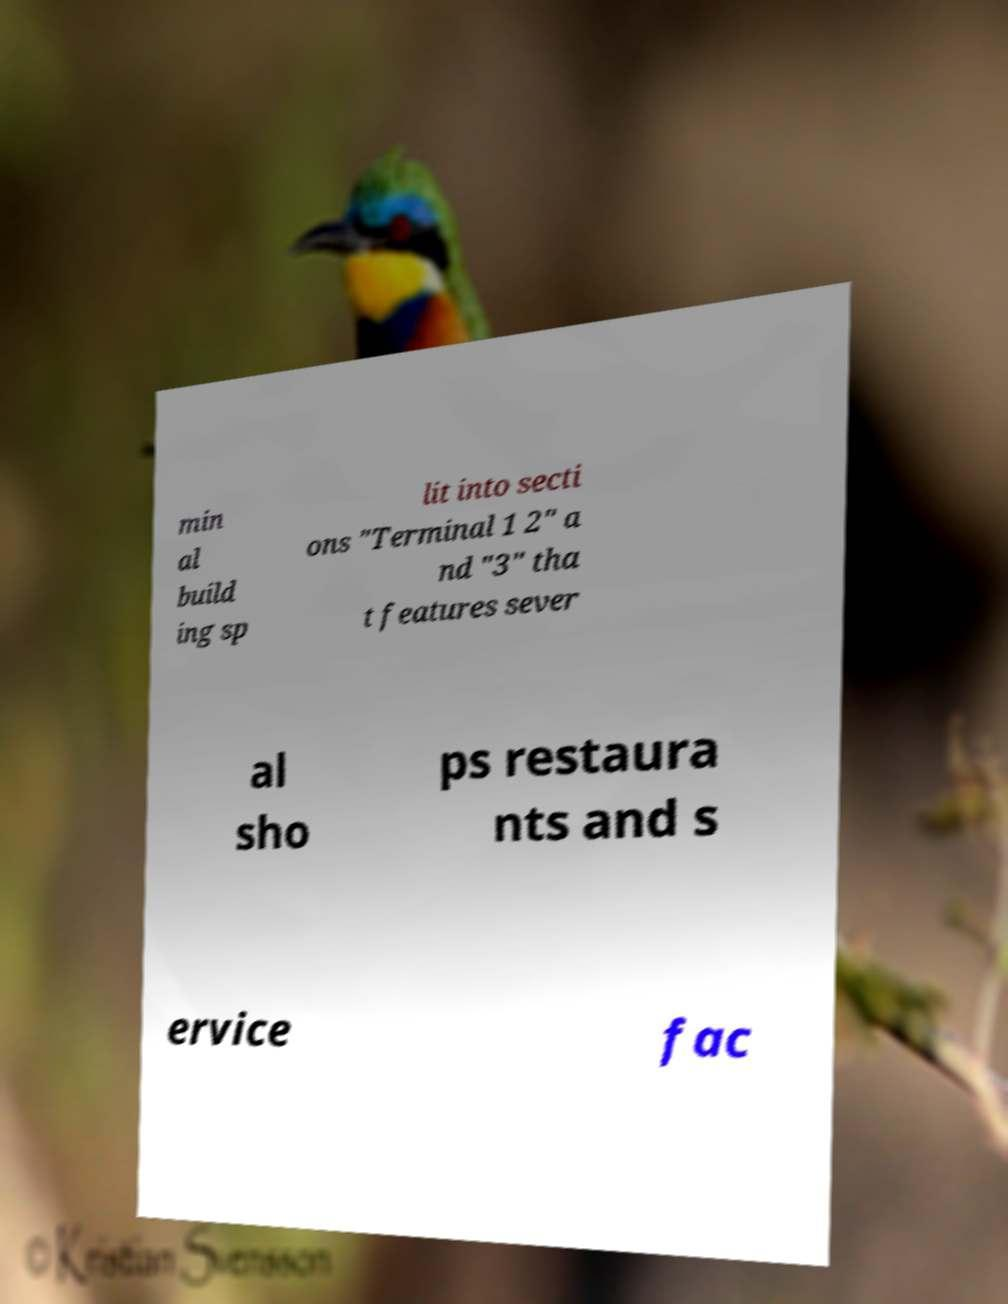What messages or text are displayed in this image? I need them in a readable, typed format. min al build ing sp lit into secti ons "Terminal 1 2" a nd "3" tha t features sever al sho ps restaura nts and s ervice fac 